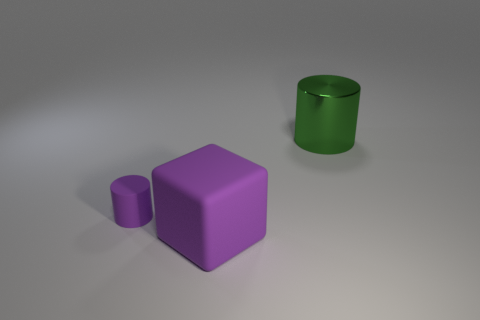There is a big cube; is its color the same as the cylinder in front of the green metal object? yes 